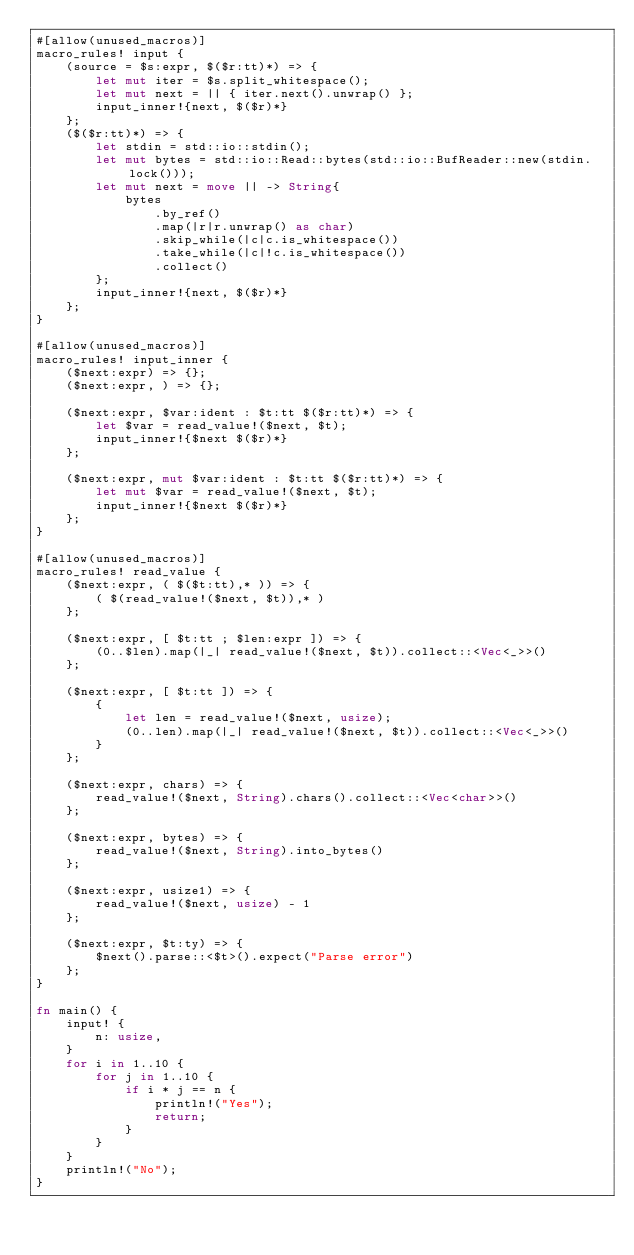Convert code to text. <code><loc_0><loc_0><loc_500><loc_500><_Rust_>#[allow(unused_macros)]
macro_rules! input {
    (source = $s:expr, $($r:tt)*) => {
        let mut iter = $s.split_whitespace();
        let mut next = || { iter.next().unwrap() };
        input_inner!{next, $($r)*}
    };
    ($($r:tt)*) => {
        let stdin = std::io::stdin();
        let mut bytes = std::io::Read::bytes(std::io::BufReader::new(stdin.lock()));
        let mut next = move || -> String{
            bytes
                .by_ref()
                .map(|r|r.unwrap() as char)
                .skip_while(|c|c.is_whitespace())
                .take_while(|c|!c.is_whitespace())
                .collect()
        };
        input_inner!{next, $($r)*}
    };
}

#[allow(unused_macros)]
macro_rules! input_inner {
    ($next:expr) => {};
    ($next:expr, ) => {};

    ($next:expr, $var:ident : $t:tt $($r:tt)*) => {
        let $var = read_value!($next, $t);
        input_inner!{$next $($r)*}
    };

    ($next:expr, mut $var:ident : $t:tt $($r:tt)*) => {
        let mut $var = read_value!($next, $t);
        input_inner!{$next $($r)*}
    };
}

#[allow(unused_macros)]
macro_rules! read_value {
    ($next:expr, ( $($t:tt),* )) => {
        ( $(read_value!($next, $t)),* )
    };

    ($next:expr, [ $t:tt ; $len:expr ]) => {
        (0..$len).map(|_| read_value!($next, $t)).collect::<Vec<_>>()
    };

    ($next:expr, [ $t:tt ]) => {
        {
            let len = read_value!($next, usize);
            (0..len).map(|_| read_value!($next, $t)).collect::<Vec<_>>()
        }
    };

    ($next:expr, chars) => {
        read_value!($next, String).chars().collect::<Vec<char>>()
    };

    ($next:expr, bytes) => {
        read_value!($next, String).into_bytes()
    };

    ($next:expr, usize1) => {
        read_value!($next, usize) - 1
    };

    ($next:expr, $t:ty) => {
        $next().parse::<$t>().expect("Parse error")
    };
}

fn main() {
    input! {
        n: usize,
    }
    for i in 1..10 {
        for j in 1..10 {
            if i * j == n {
                println!("Yes");
                return;
            }
        }
    }
    println!("No");
}
</code> 